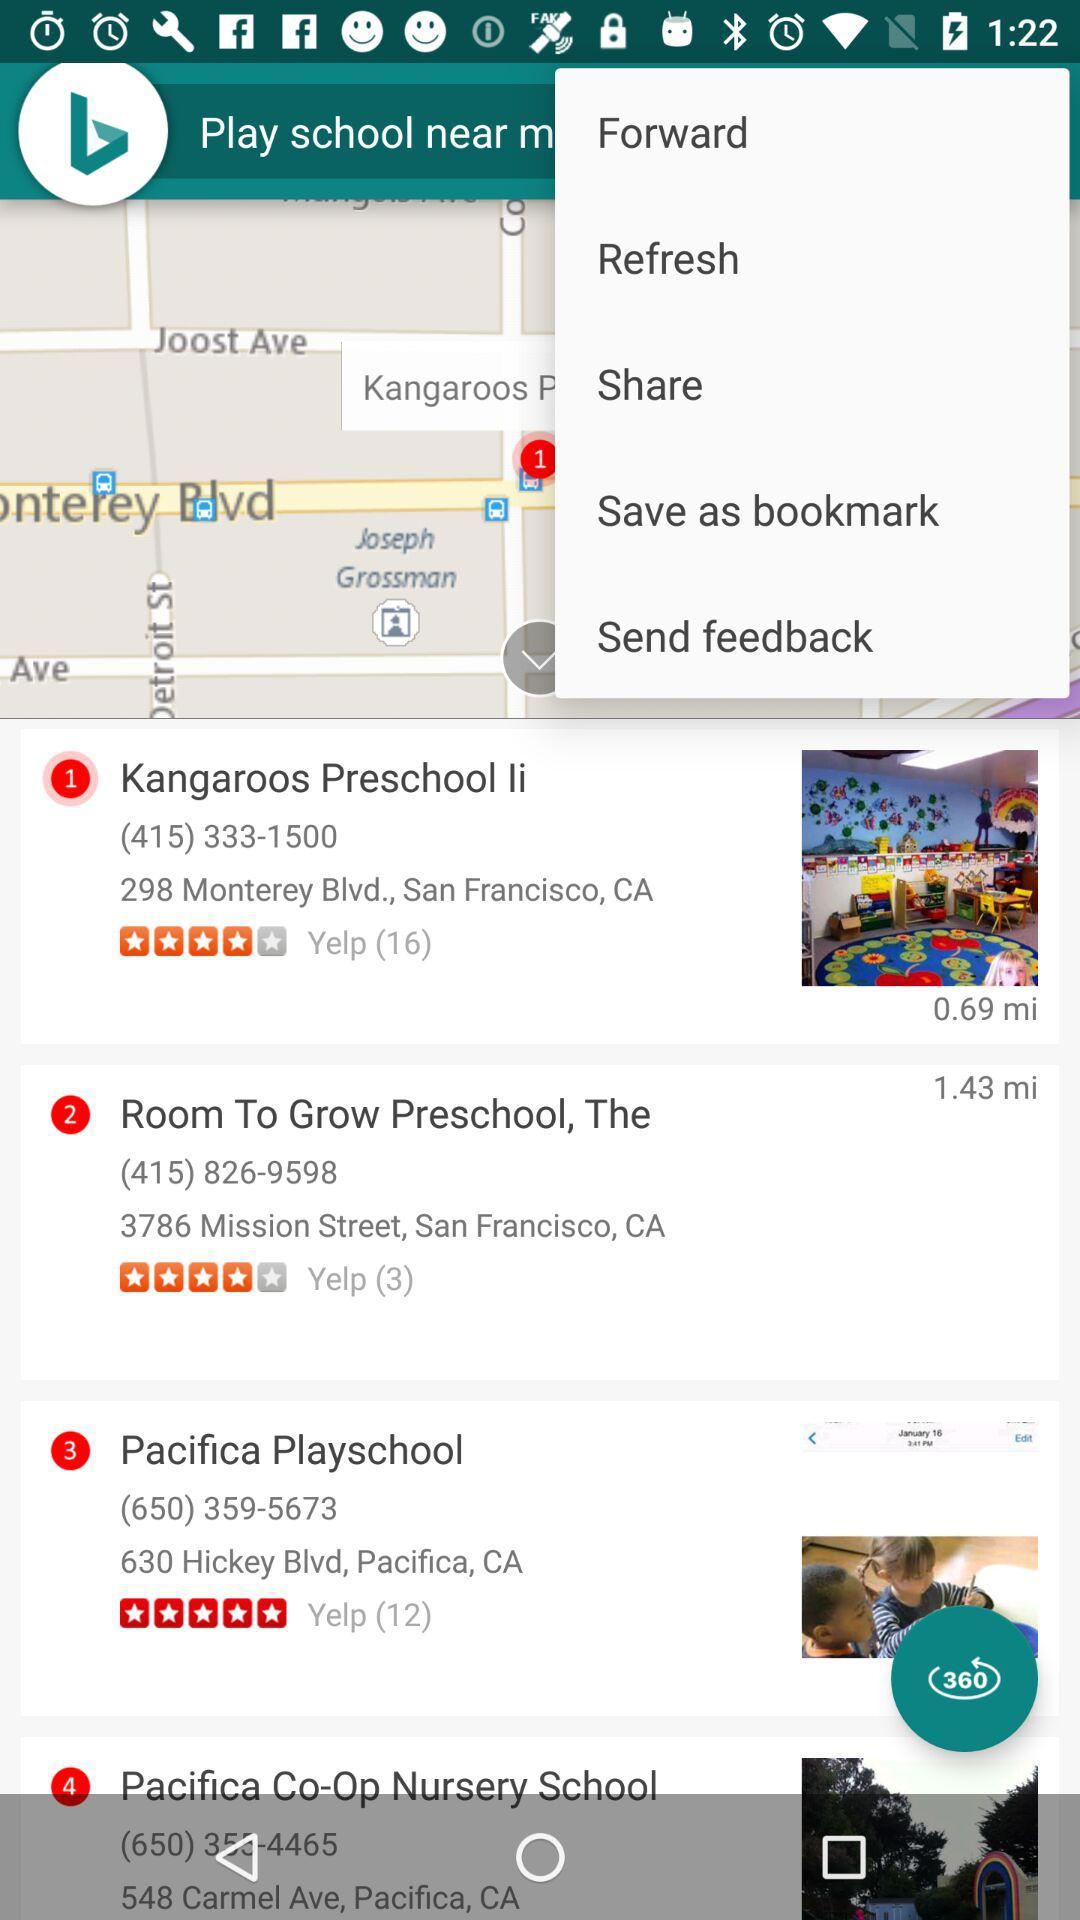Which option is selected in the drop-down menu?
When the provided information is insufficient, respond with <no answer>. <no answer> 